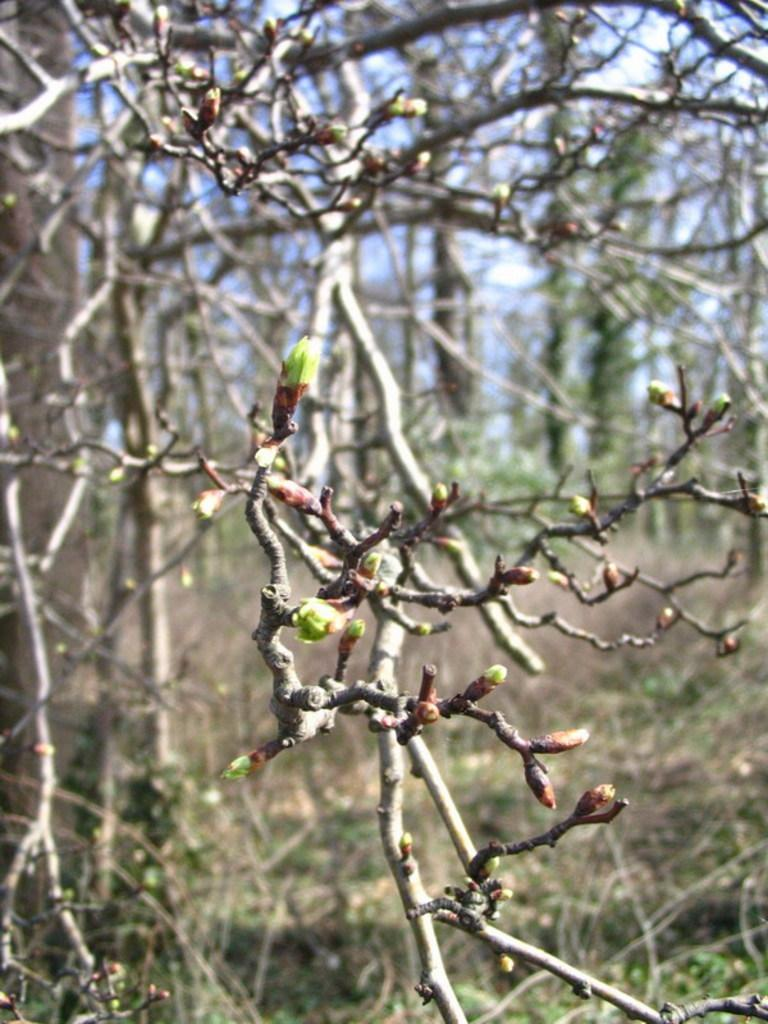What can be seen in the foreground of the image? There are trees in the foreground of the image. What is visible in the background of the image? There is a group of trees in the background of the image. What type of invention can be seen hanging from the trees in the image? There is no invention present in the image; it only features trees in the foreground and background. 